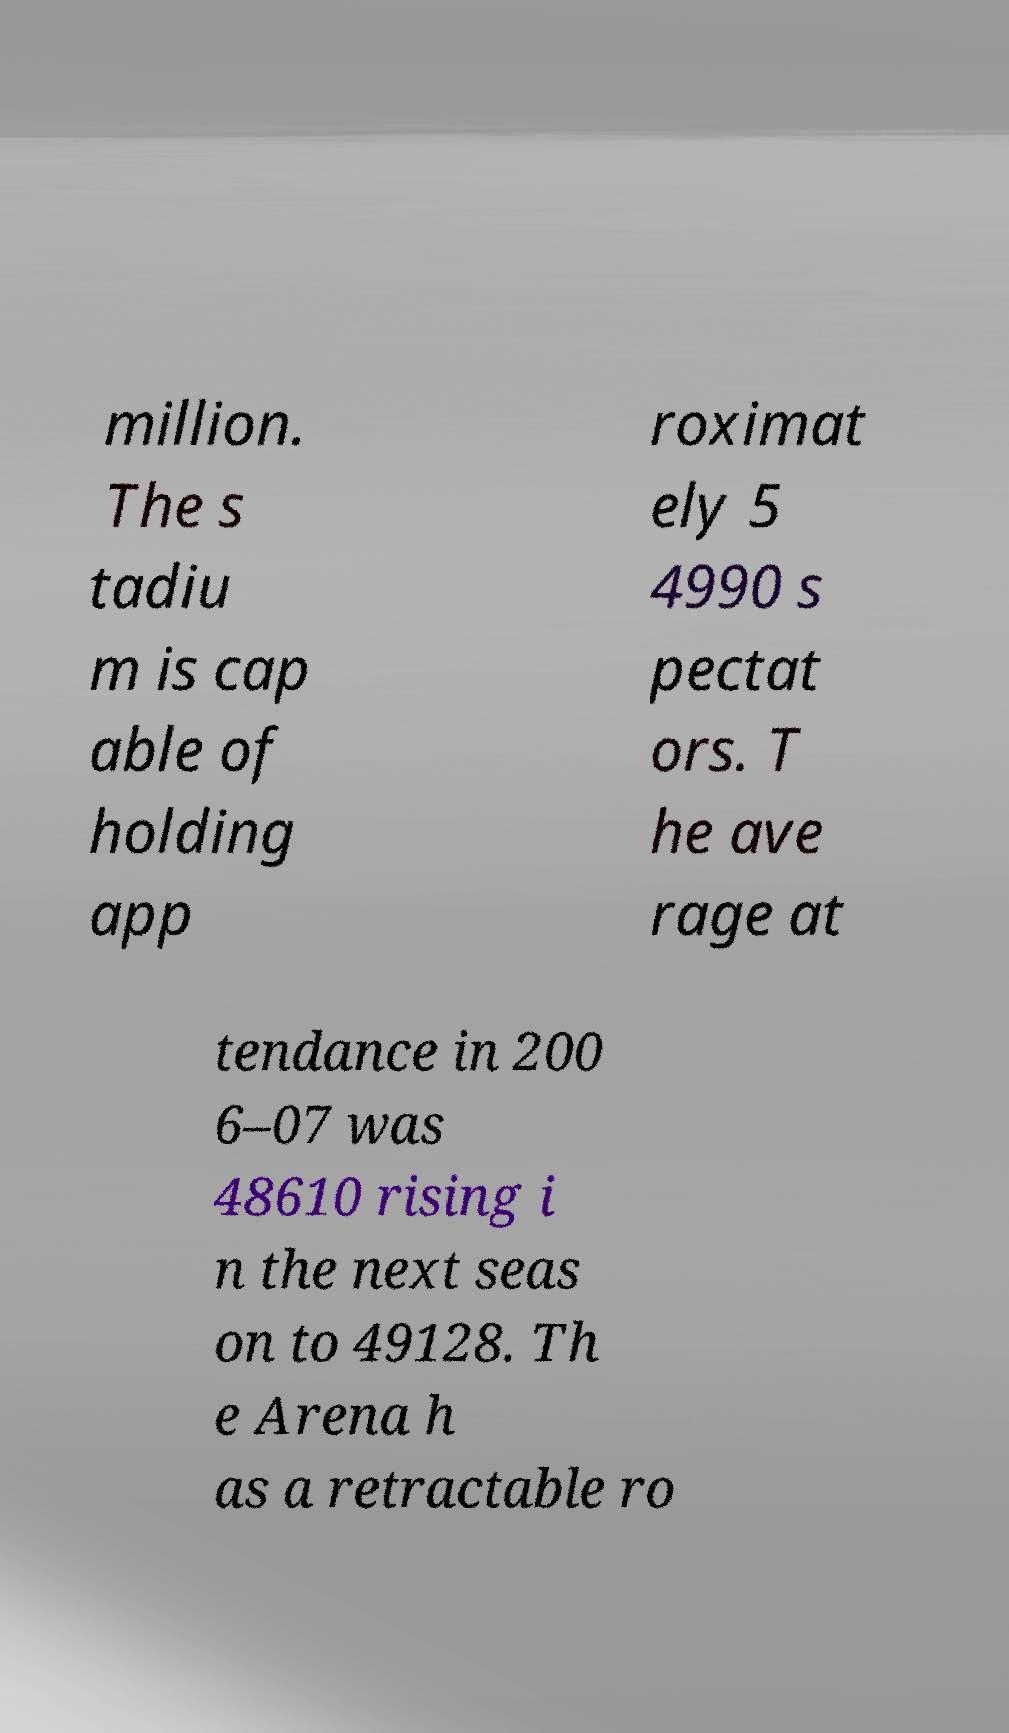Please identify and transcribe the text found in this image. million. The s tadiu m is cap able of holding app roximat ely 5 4990 s pectat ors. T he ave rage at tendance in 200 6–07 was 48610 rising i n the next seas on to 49128. Th e Arena h as a retractable ro 